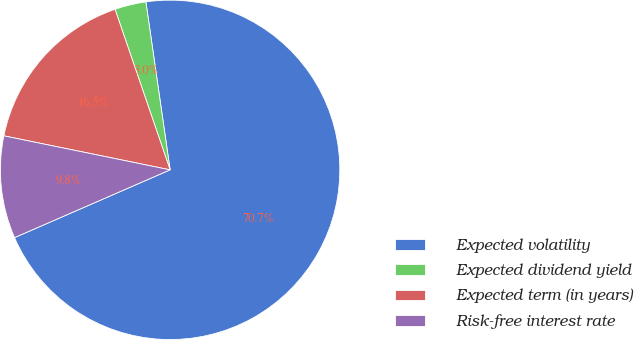Convert chart. <chart><loc_0><loc_0><loc_500><loc_500><pie_chart><fcel>Expected volatility<fcel>Expected dividend yield<fcel>Expected term (in years)<fcel>Risk-free interest rate<nl><fcel>70.74%<fcel>2.98%<fcel>16.53%<fcel>9.75%<nl></chart> 